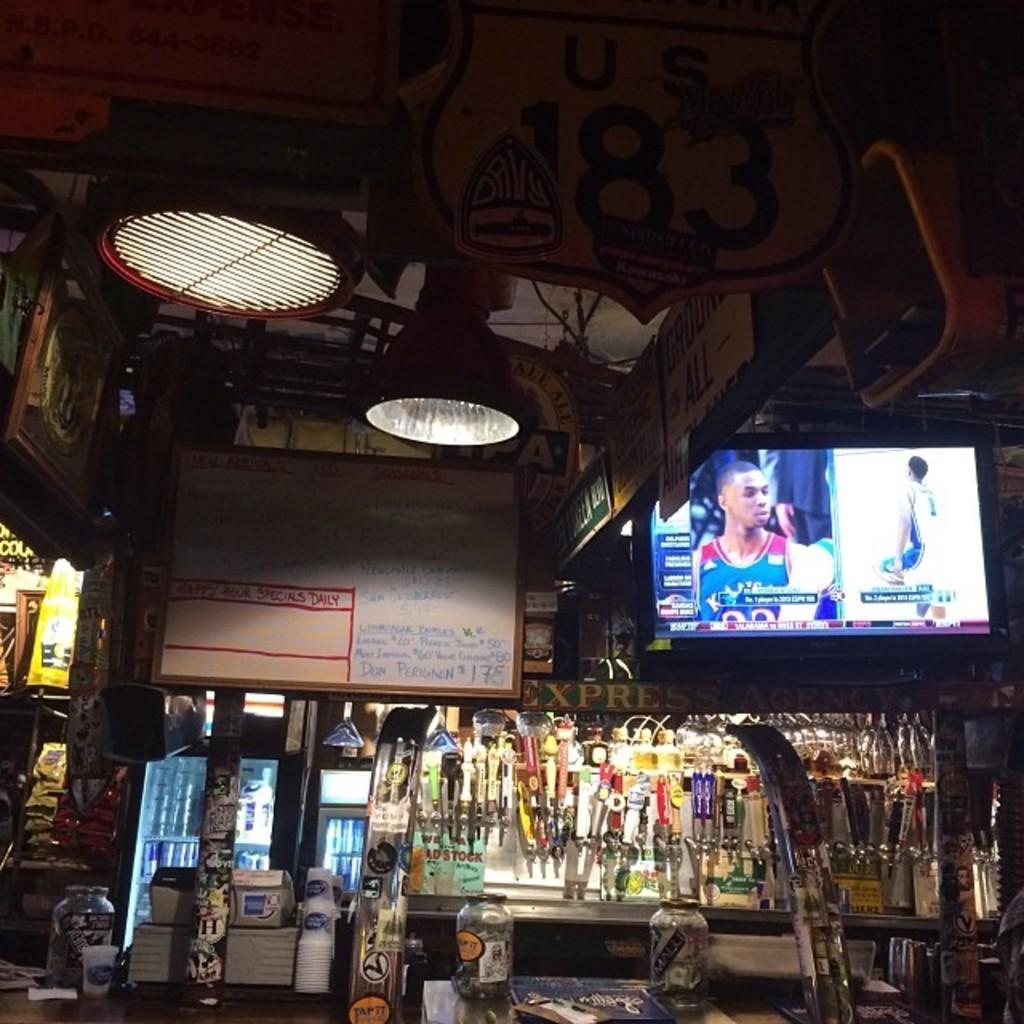In one or two sentences, can you explain what this image depicts? In this picture I can see the television screen. In that I can see the player who are playing the basketball. At the bottom I can see many equipment. On the bottom left corner I can see the boxes near to the door. At the top I can see the lights & boards. At the bottom there are jars on the table. On the left there is a white boards which is placed near to the wall. 